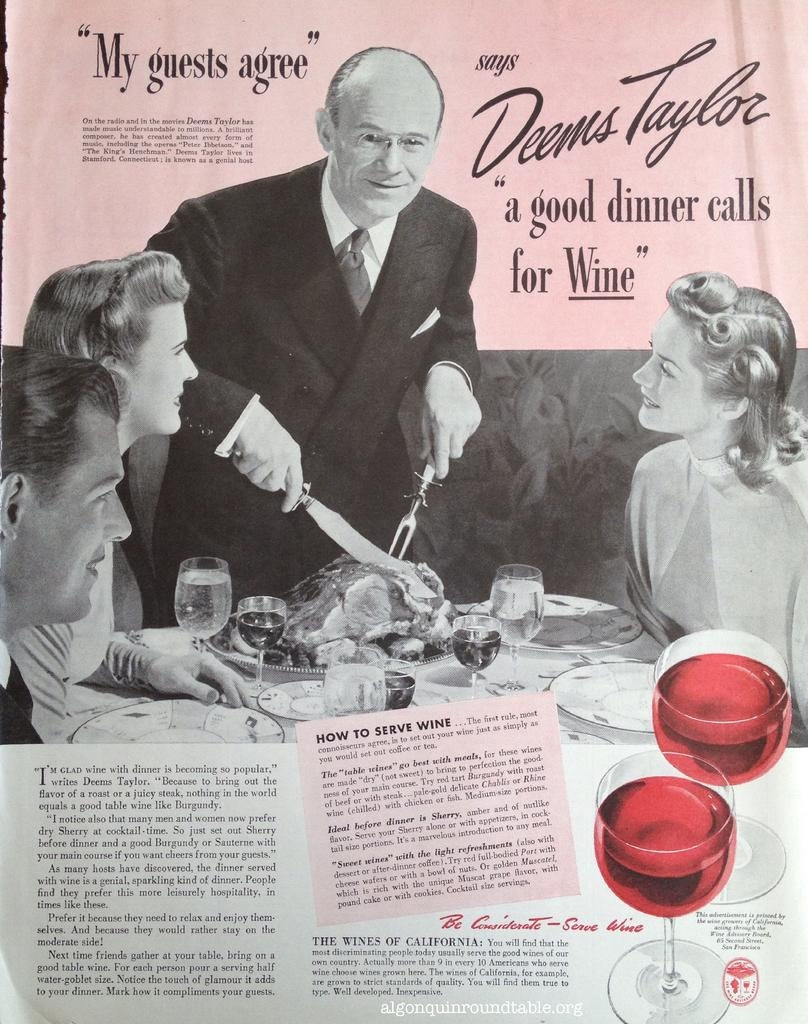What is present on the wall in the image? There is a poster in the image. What can be seen on the poster? The poster contains images of people. What objects are on the table in the image? There are glasses and plates on the table in the image. What is on the plates in the image? There is food on the plates in the image. What additional information is provided by the poster? There is some information on the poster. How much sugar is present in the zinc on the table in the image? There is no sugar or zinc present on the table in the image. What type of use is the poster being put to in the image? The poster is not being used for any specific purpose in the image; it is simply hanging on the wall. 